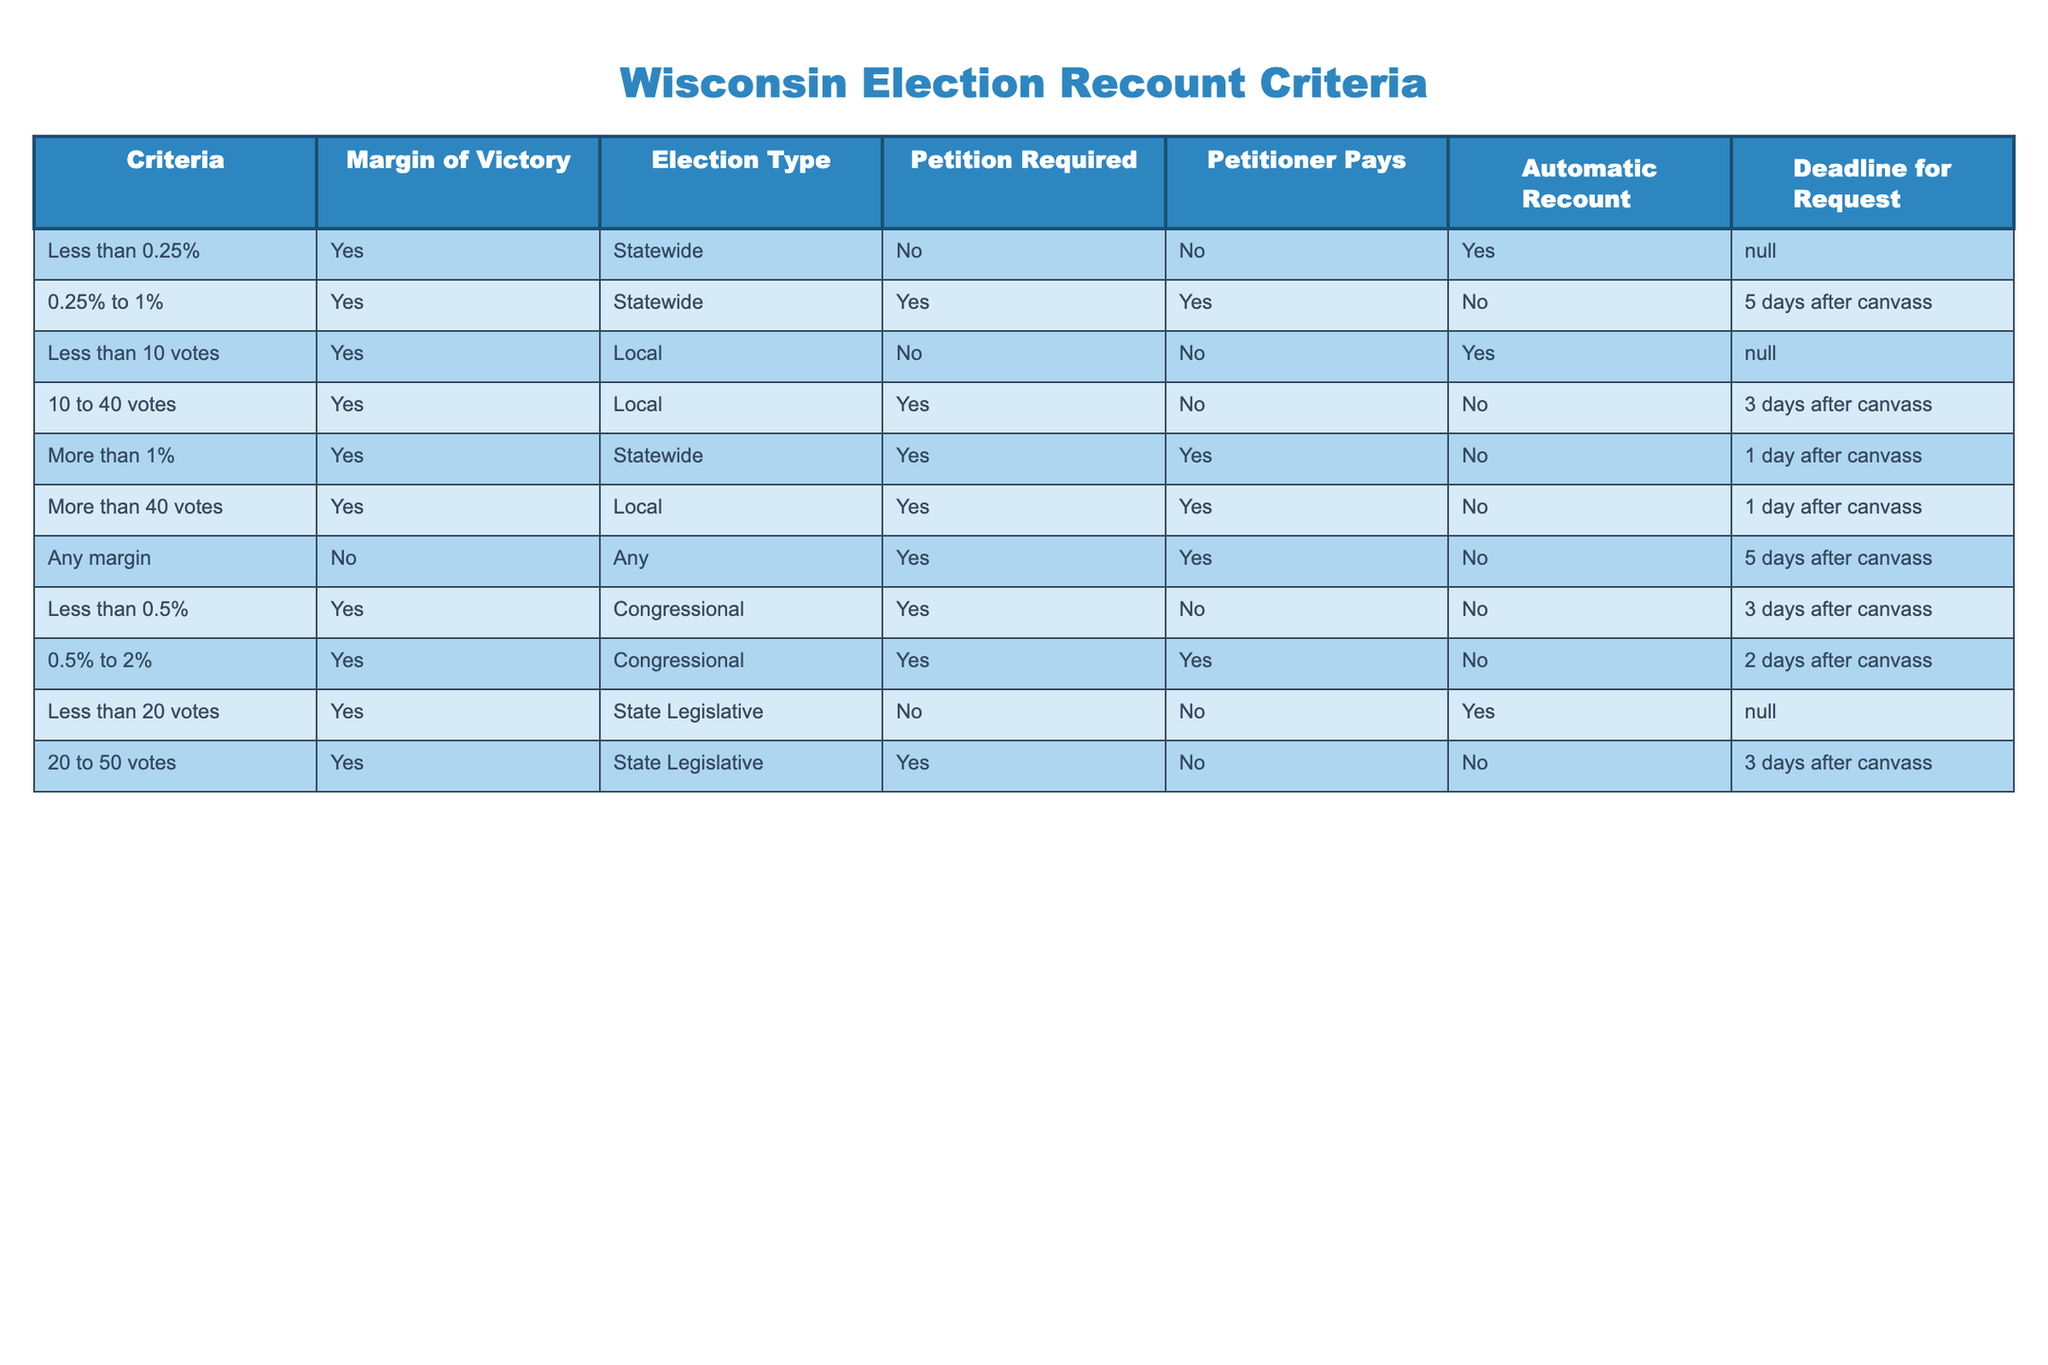What is the margin of victory limit for requiring an automatic recount in a state-wide election? According to the table, the margin of victory limit for requiring an automatic recount is less than 0.25%. In that case, an automatic recount is mandated.
Answer: Less than 0.25% What is the deadline for requesting a recount for a local election where the margin is between 10 and 40 votes? The table shows that for a local election with a margin between 10 and 40 votes, the deadline to request a recount is 3 days after the canvass.
Answer: 3 days after canvass Is a petitioner required to pay for a recount request in a congressional election with a margin of less than 0.5%? The table indicates that in a congressional election with a margin of less than 0.5%, the petitioner is required to pay for a recount request.
Answer: Yes What is the automatic recount condition for a statewide election with a margin of victory greater than 1%? The table states that if the margin of victory is greater than 1% in a statewide election, an automatic recount is not available, regardless of other factors.
Answer: No For local elections, how many criteria require a petition? In the table, criteria that require a petition for local elections include a margin of victory from 10 to 40 votes and more than 40 votes. Therefore, there are 2 criteria that require a petition.
Answer: 2 Which types of elections have an automatic recount for a margin of victory less than 20 votes? The table specifies that local elections with a margin of victory less than 10 votes, as well as state legislative elections with a margin less than 20 votes, both allow for an automatic recount.
Answer: Local and State Legislative If the margin of victory is between 0.25% and 1% for a statewide election, is a recount possible? The table states that for a marginal victory between 0.25% and 1%, a recount is possible only with a petition that requires payment, which means a recount can occur under those conditions.
Answer: Yes What is the time frame for requesting a recount for congressional elections with a margin of 0.5% to 2%? According to the table, for congressional elections with a margin of 0.5% to 2%, the time frame to request a recount is 2 days after the canvass.
Answer: 2 days after canvass In local elections, what is the relationship between the number of votes and the requirement for a petition? The table illustrates that for local elections with a margin of less than 10 votes, no petition is required, whereas margins between 10 to 40 votes and over 40 votes do require a petition.
Answer: Margins 10-40 and over 40 require a petition, less than 10 does not 